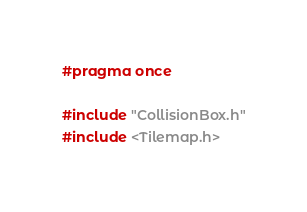<code> <loc_0><loc_0><loc_500><loc_500><_C_>#pragma once

#include "CollisionBox.h"
#include <Tilemap.h></code> 